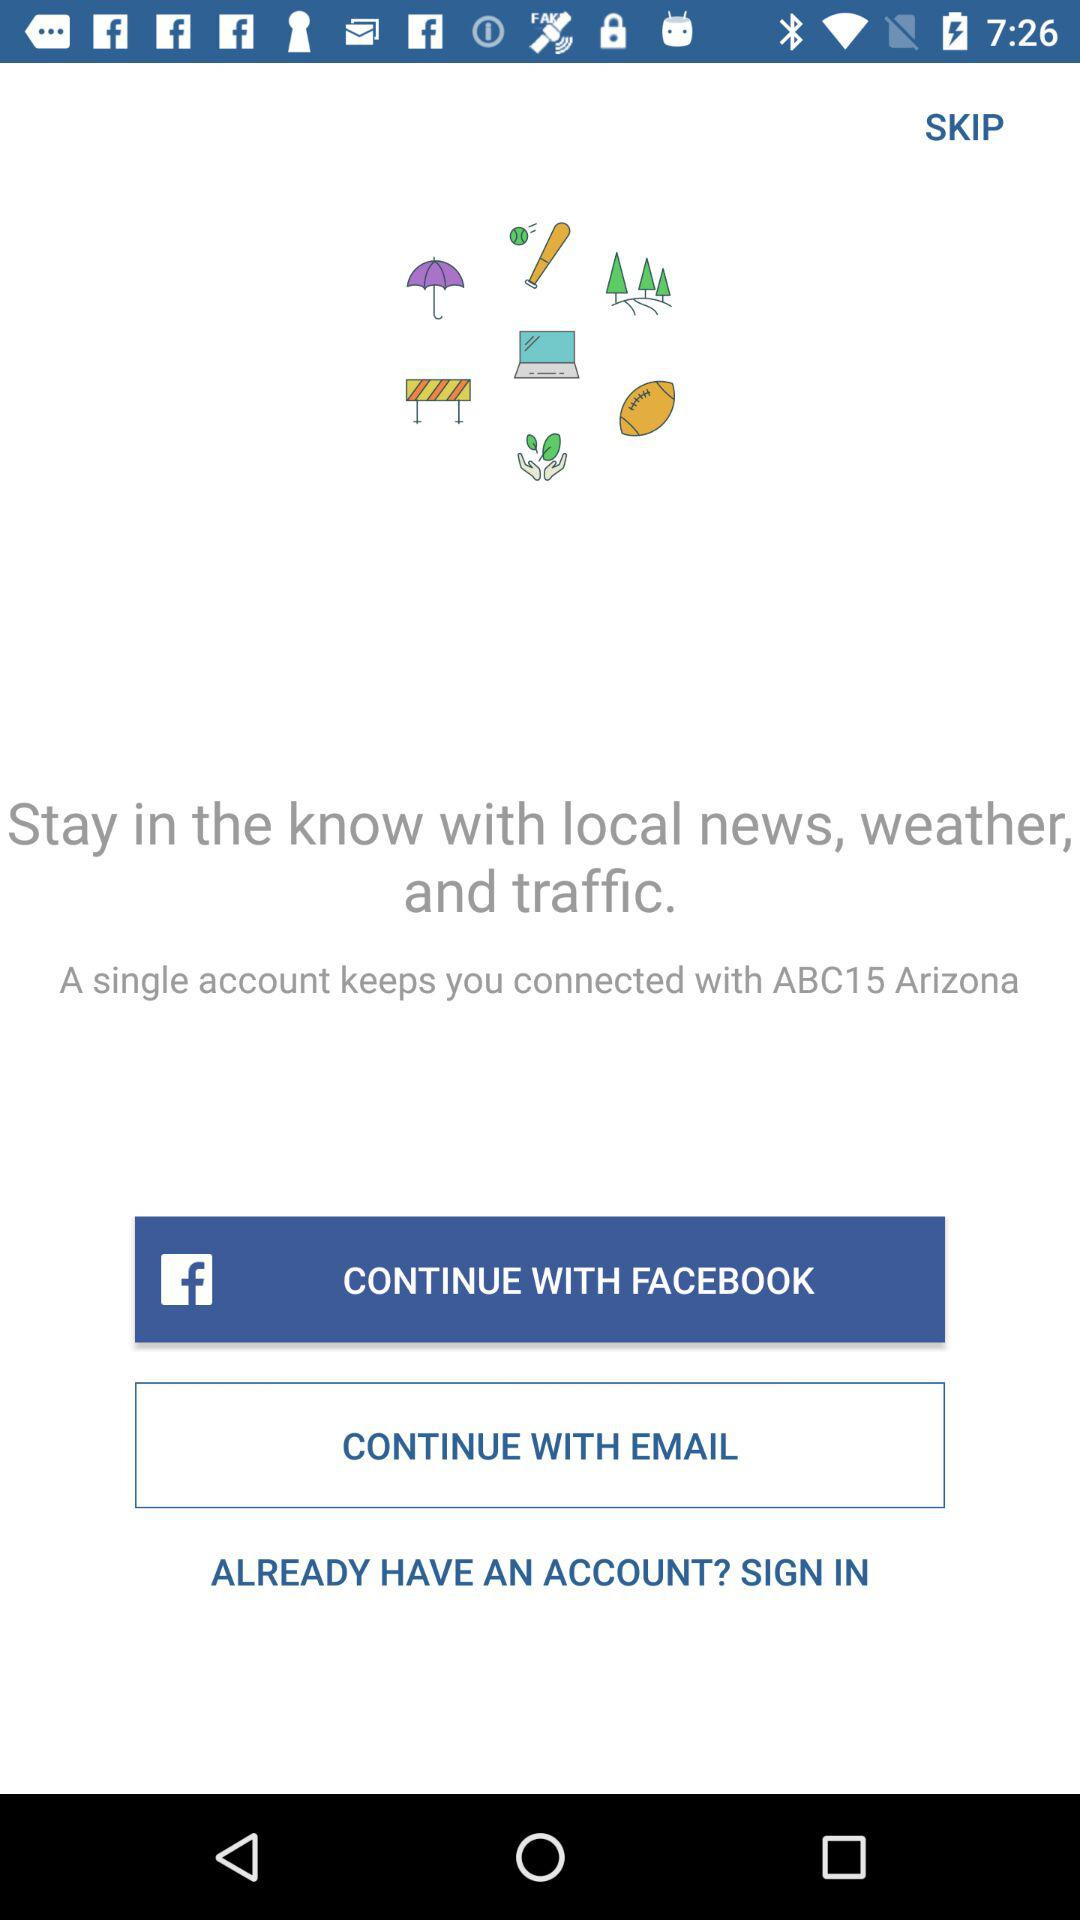With which application can we sign in? You can sign in with "FACEBOOK". 